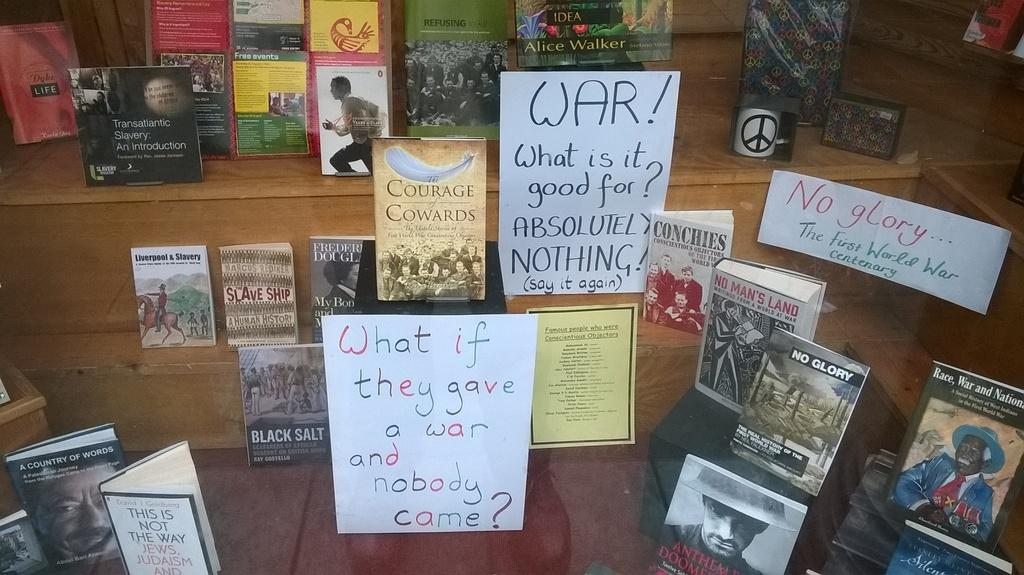Provide a one-sentence caption for the provided image. A book display that also features some anti war slogans. 